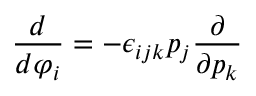<formula> <loc_0><loc_0><loc_500><loc_500>\frac { d } { d \varphi _ { i } } = - \epsilon _ { i j k } p _ { j } \frac { \partial } { \partial p _ { k } }</formula> 